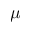Convert formula to latex. <formula><loc_0><loc_0><loc_500><loc_500>\mu</formula> 